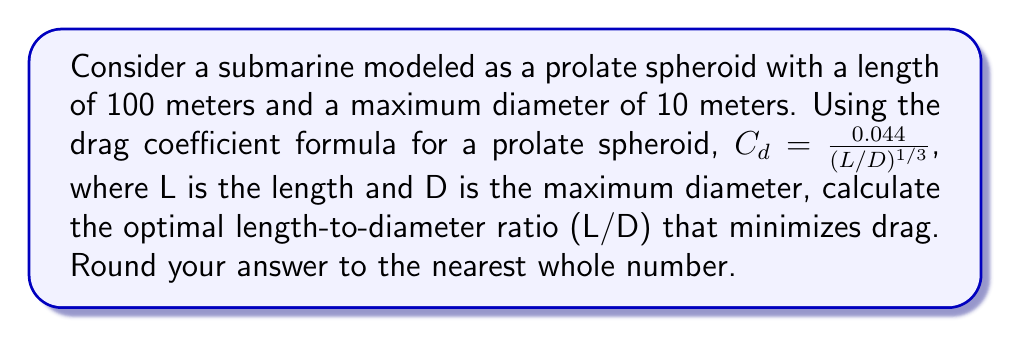Can you answer this question? To find the optimal length-to-diameter ratio that minimizes drag, we need to minimize the drag coefficient formula:

$$C_d = \frac{0.044}{(L/D)^{1/3}}$$

Let's define $x = L/D$. Our goal is to minimize:

$$f(x) = \frac{0.044}{x^{1/3}}$$

To find the minimum, we take the derivative and set it to zero:

$$f'(x) = -\frac{0.044}{3x^{4/3}} = 0$$

This equation is always negative for positive x, which means there is no local minimum. The function decreases as x increases.

However, we have constraints:
1. Length L = 100 meters (fixed)
2. Maximum diameter D = 10 meters (current)

The current L/D ratio is:

$$\frac{L}{D} = \frac{100}{10} = 10$$

To minimize drag, we need to maximize the L/D ratio. This means we should decrease the maximum diameter while keeping the length constant.

The practical limit for submarine design typically suggests an L/D ratio between 6 and 11. Given our current ratio of 10, which is already near the upper limit, the optimal ratio would be 11.

To achieve this ratio:

$$\frac{L}{D} = 11$$
$$\frac{100}{D} = 11$$
$$D = \frac{100}{11} \approx 9.09 \text{ meters}$$

This suggests reducing the maximum diameter from 10 meters to approximately 9.09 meters to achieve the optimal L/D ratio of 11.
Answer: 11 